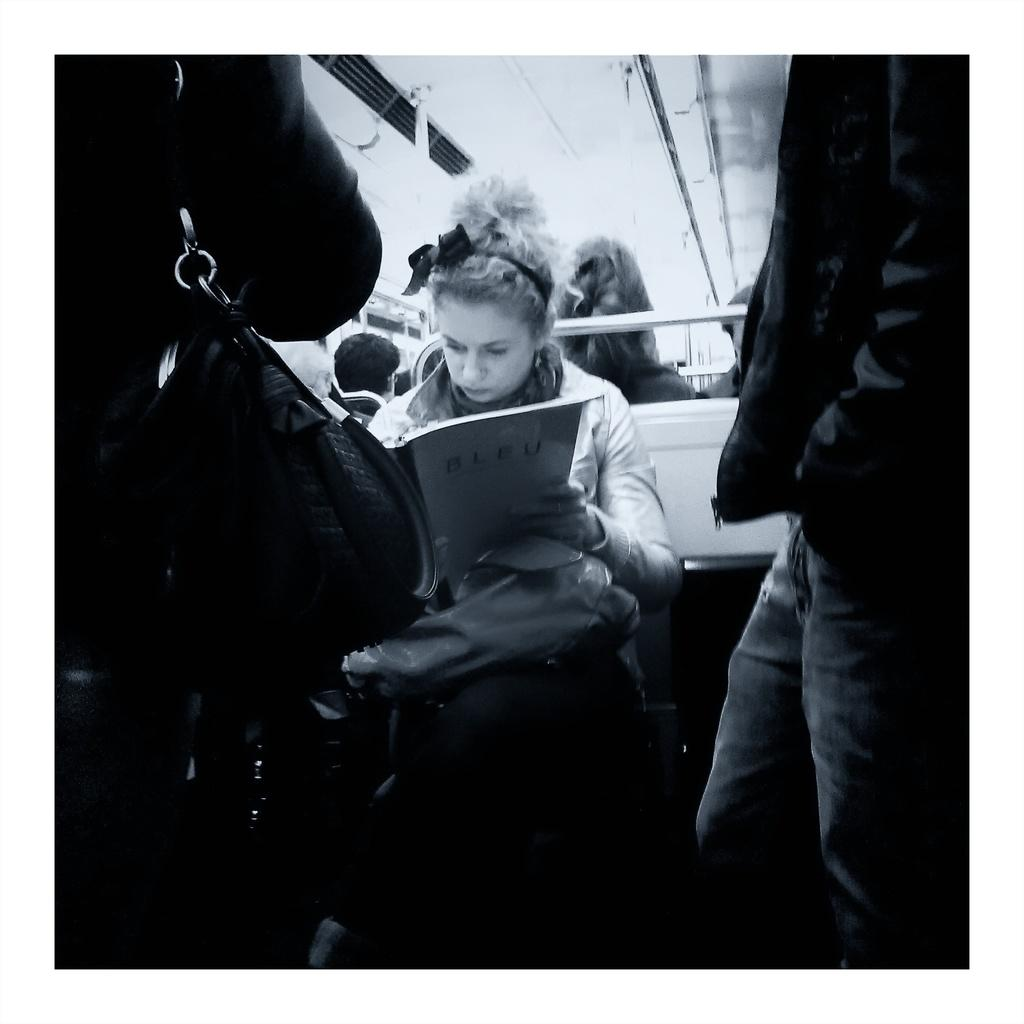How many people are in the image? There are people in the image, but the exact number is not specified. What is the woman in the image doing? The woman is sitting and holding a book. What object can be seen in the image that resembles a long, thin bar? There is a rod in the image. Can you describe the person on the left side of the image? A person is carrying a bag on the left side of the image. What type of horse can be seen in the image? There is no horse present in the image. What color is the pen being used by the person in the image? There is no pen visible in the image. 